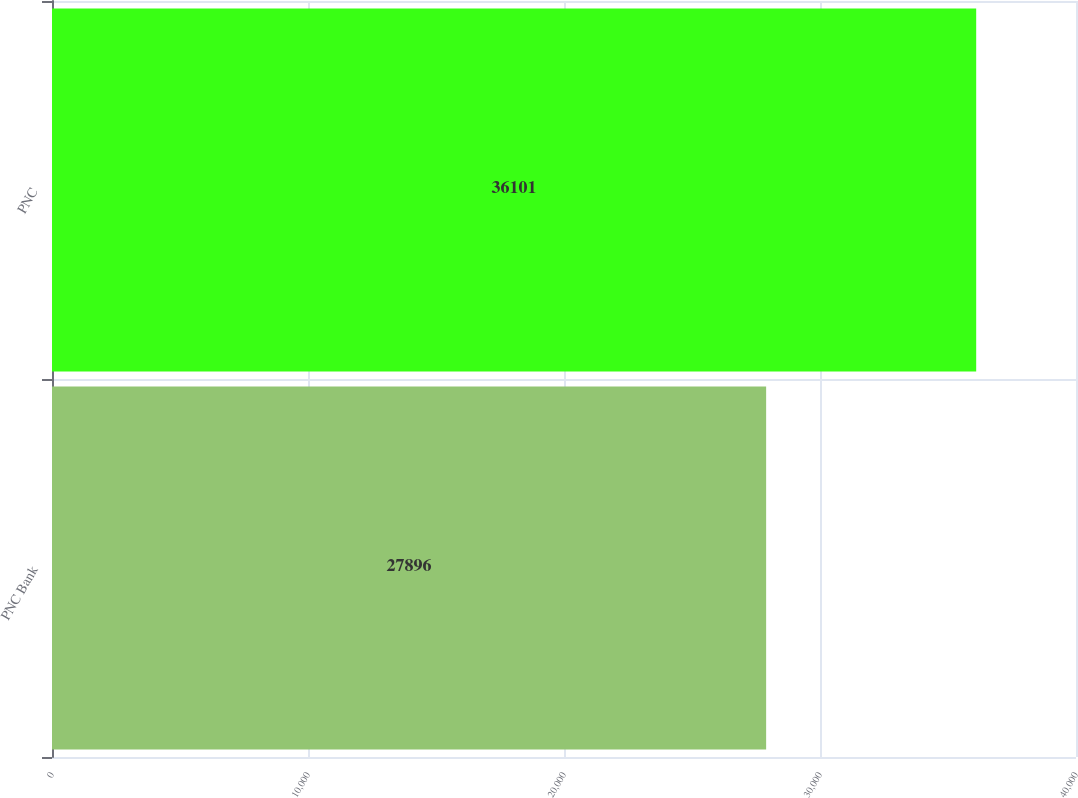Convert chart. <chart><loc_0><loc_0><loc_500><loc_500><bar_chart><fcel>PNC Bank<fcel>PNC<nl><fcel>27896<fcel>36101<nl></chart> 